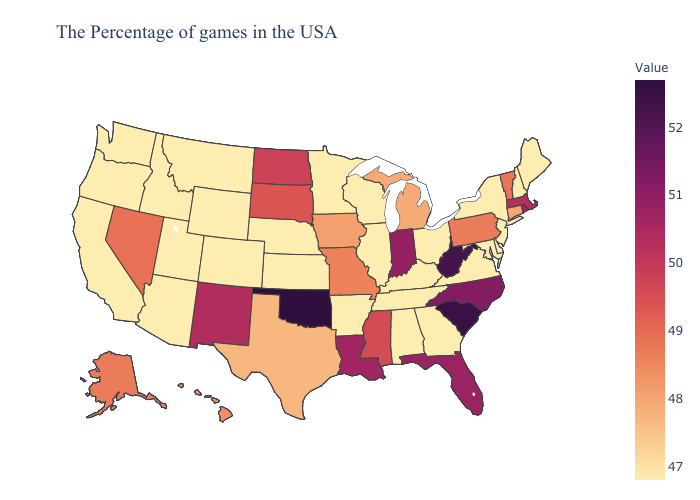Does Indiana have the highest value in the MidWest?
Short answer required. Yes. Which states have the lowest value in the South?
Write a very short answer. Delaware, Maryland, Virginia, Georgia, Kentucky, Alabama, Tennessee, Arkansas. Which states have the highest value in the USA?
Give a very brief answer. Oklahoma. Does Pennsylvania have the highest value in the USA?
Short answer required. No. Does Indiana have the highest value in the MidWest?
Write a very short answer. Yes. 